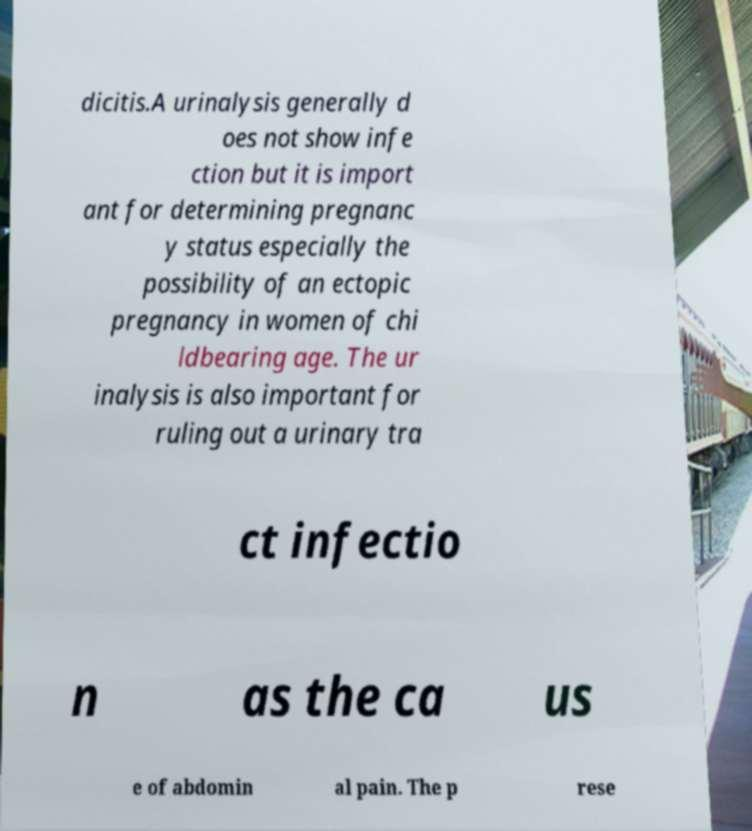There's text embedded in this image that I need extracted. Can you transcribe it verbatim? dicitis.A urinalysis generally d oes not show infe ction but it is import ant for determining pregnanc y status especially the possibility of an ectopic pregnancy in women of chi ldbearing age. The ur inalysis is also important for ruling out a urinary tra ct infectio n as the ca us e of abdomin al pain. The p rese 